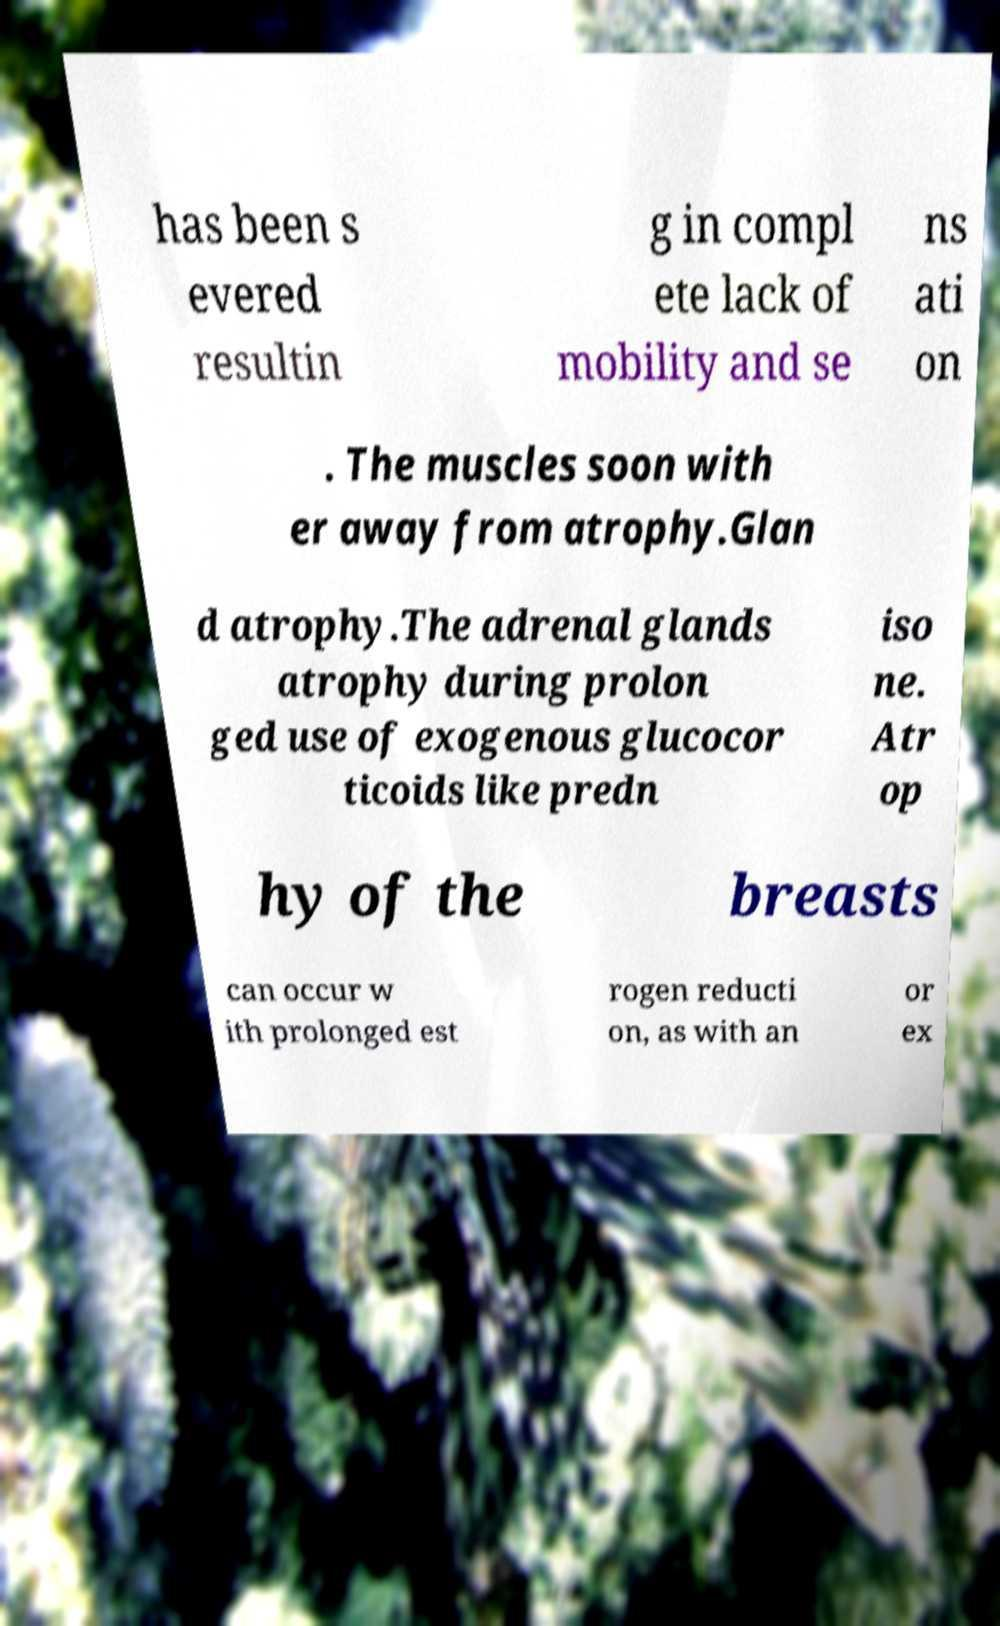What messages or text are displayed in this image? I need them in a readable, typed format. has been s evered resultin g in compl ete lack of mobility and se ns ati on . The muscles soon with er away from atrophy.Glan d atrophy.The adrenal glands atrophy during prolon ged use of exogenous glucocor ticoids like predn iso ne. Atr op hy of the breasts can occur w ith prolonged est rogen reducti on, as with an or ex 